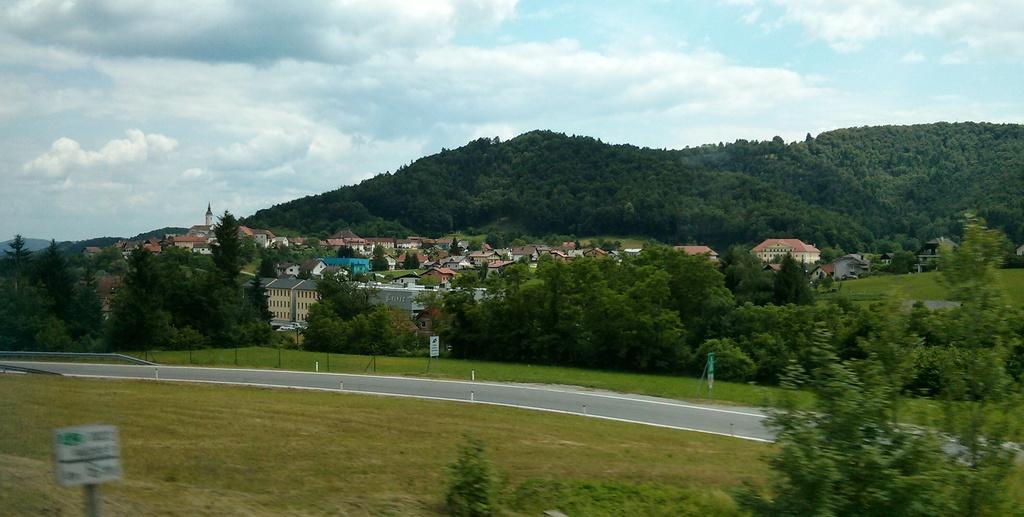Describe this image in one or two sentences. In this image we can see there are trees, plants, boards, grass and road. In the background there are houses and sky. 